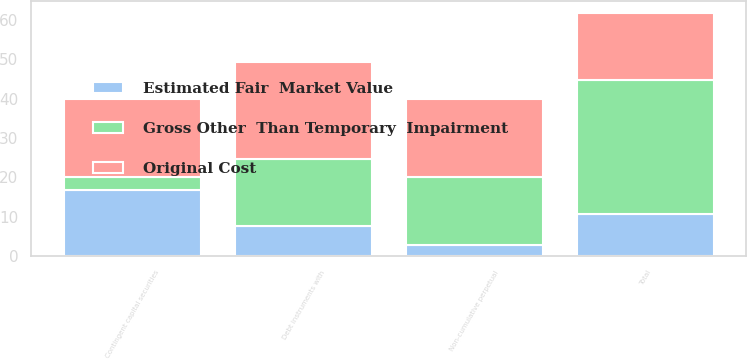Convert chart to OTSL. <chart><loc_0><loc_0><loc_500><loc_500><stacked_bar_chart><ecel><fcel>Debt instruments with<fcel>Non-cumulative perpetual<fcel>Total<fcel>Contingent capital securities<nl><fcel>Original Cost<fcel>24.7<fcel>20<fcel>17<fcel>20<nl><fcel>Gross Other  Than Temporary  Impairment<fcel>17<fcel>17<fcel>34<fcel>3.2<nl><fcel>Estimated Fair  Market Value<fcel>7.7<fcel>3<fcel>10.7<fcel>16.8<nl></chart> 